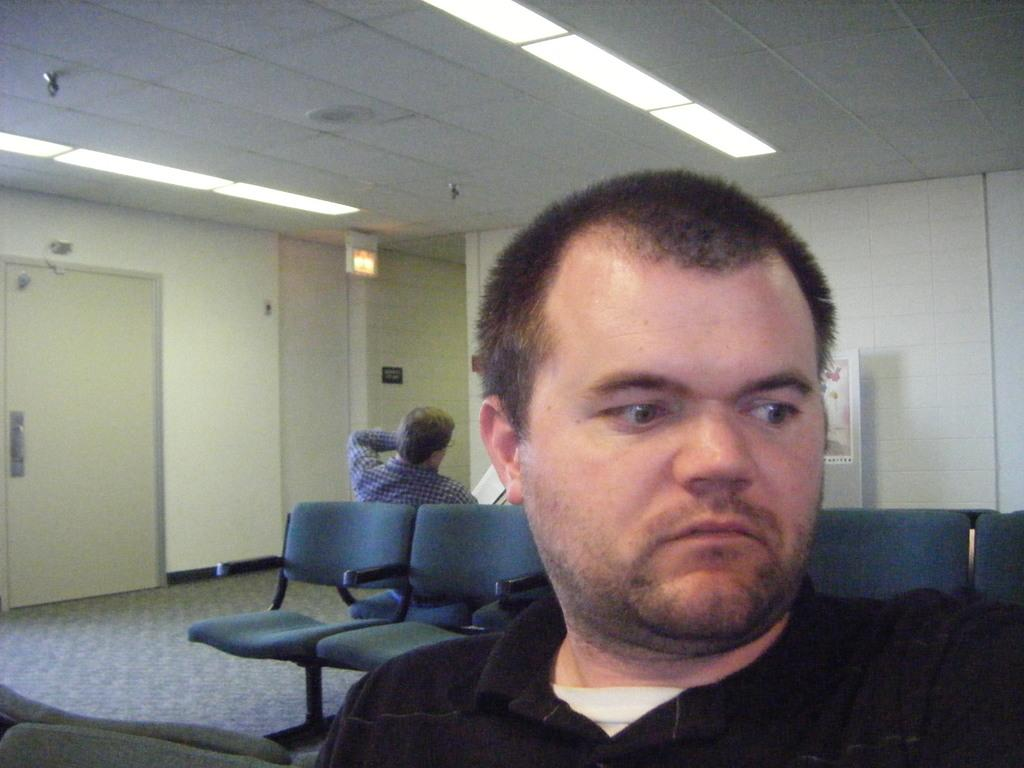How many people are in the image? There are two persons in the image. What are the persons doing in the image? The persons are sitting on chairs. Can you describe any architectural features in the image? Yes, there is a door in the image. What is the color of the wall in the image? The wall in the image is white. What type of crime is being committed in the image? There is no indication of a crime being committed in the image. Can you see any sea creatures in the image? There are no sea creatures present in the image. 